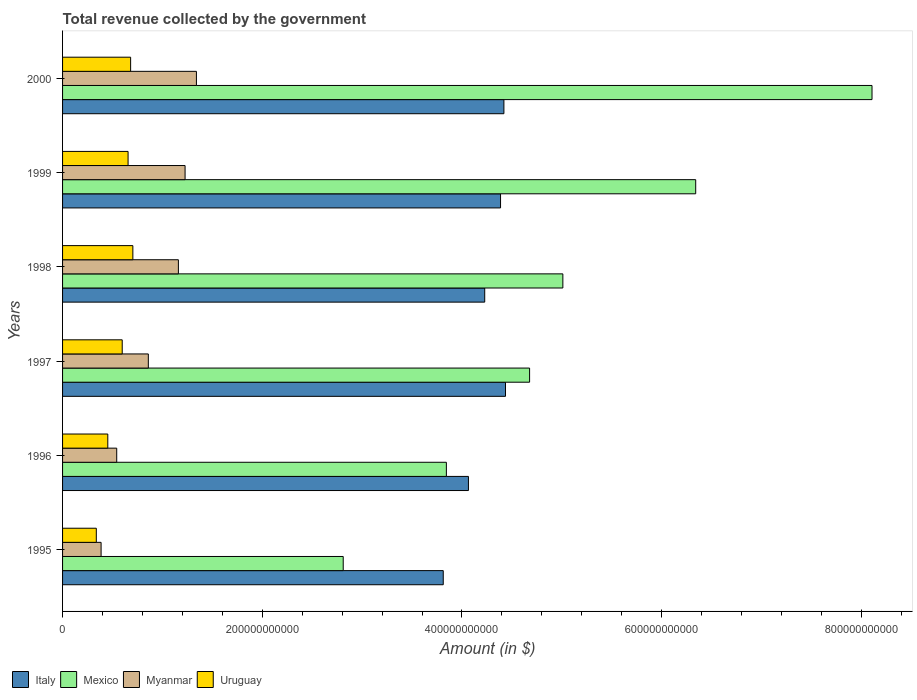How many groups of bars are there?
Provide a short and direct response. 6. Are the number of bars per tick equal to the number of legend labels?
Your answer should be very brief. Yes. Are the number of bars on each tick of the Y-axis equal?
Make the answer very short. Yes. What is the total revenue collected by the government in Italy in 1995?
Ensure brevity in your answer.  3.81e+11. Across all years, what is the maximum total revenue collected by the government in Myanmar?
Provide a succinct answer. 1.34e+11. Across all years, what is the minimum total revenue collected by the government in Italy?
Your answer should be very brief. 3.81e+11. In which year was the total revenue collected by the government in Italy maximum?
Give a very brief answer. 1997. In which year was the total revenue collected by the government in Myanmar minimum?
Keep it short and to the point. 1995. What is the total total revenue collected by the government in Italy in the graph?
Make the answer very short. 2.53e+12. What is the difference between the total revenue collected by the government in Myanmar in 1996 and that in 1997?
Provide a succinct answer. -3.17e+1. What is the difference between the total revenue collected by the government in Uruguay in 1998 and the total revenue collected by the government in Mexico in 1995?
Offer a very short reply. -2.11e+11. What is the average total revenue collected by the government in Uruguay per year?
Your answer should be very brief. 5.72e+1. In the year 1999, what is the difference between the total revenue collected by the government in Italy and total revenue collected by the government in Mexico?
Provide a succinct answer. -1.95e+11. What is the ratio of the total revenue collected by the government in Myanmar in 1996 to that in 1997?
Provide a succinct answer. 0.63. Is the total revenue collected by the government in Mexico in 1996 less than that in 1998?
Your response must be concise. Yes. Is the difference between the total revenue collected by the government in Italy in 1998 and 1999 greater than the difference between the total revenue collected by the government in Mexico in 1998 and 1999?
Your response must be concise. Yes. What is the difference between the highest and the second highest total revenue collected by the government in Italy?
Make the answer very short. 1.59e+09. What is the difference between the highest and the lowest total revenue collected by the government in Mexico?
Ensure brevity in your answer.  5.30e+11. In how many years, is the total revenue collected by the government in Uruguay greater than the average total revenue collected by the government in Uruguay taken over all years?
Provide a short and direct response. 4. Is the sum of the total revenue collected by the government in Mexico in 1998 and 2000 greater than the maximum total revenue collected by the government in Italy across all years?
Your response must be concise. Yes. Is it the case that in every year, the sum of the total revenue collected by the government in Mexico and total revenue collected by the government in Italy is greater than the sum of total revenue collected by the government in Myanmar and total revenue collected by the government in Uruguay?
Provide a succinct answer. No. What does the 2nd bar from the bottom in 1999 represents?
Provide a short and direct response. Mexico. Is it the case that in every year, the sum of the total revenue collected by the government in Uruguay and total revenue collected by the government in Myanmar is greater than the total revenue collected by the government in Mexico?
Provide a succinct answer. No. How many bars are there?
Make the answer very short. 24. Are all the bars in the graph horizontal?
Provide a succinct answer. Yes. What is the difference between two consecutive major ticks on the X-axis?
Offer a terse response. 2.00e+11. Does the graph contain any zero values?
Make the answer very short. No. Does the graph contain grids?
Make the answer very short. No. Where does the legend appear in the graph?
Provide a short and direct response. Bottom left. What is the title of the graph?
Offer a very short reply. Total revenue collected by the government. Does "Andorra" appear as one of the legend labels in the graph?
Offer a very short reply. No. What is the label or title of the X-axis?
Offer a very short reply. Amount (in $). What is the label or title of the Y-axis?
Your answer should be compact. Years. What is the Amount (in $) in Italy in 1995?
Your response must be concise. 3.81e+11. What is the Amount (in $) in Mexico in 1995?
Make the answer very short. 2.81e+11. What is the Amount (in $) of Myanmar in 1995?
Keep it short and to the point. 3.86e+1. What is the Amount (in $) of Uruguay in 1995?
Provide a short and direct response. 3.38e+1. What is the Amount (in $) of Italy in 1996?
Offer a very short reply. 4.06e+11. What is the Amount (in $) of Mexico in 1996?
Keep it short and to the point. 3.84e+11. What is the Amount (in $) of Myanmar in 1996?
Offer a terse response. 5.42e+1. What is the Amount (in $) in Uruguay in 1996?
Keep it short and to the point. 4.53e+1. What is the Amount (in $) in Italy in 1997?
Offer a terse response. 4.44e+11. What is the Amount (in $) of Mexico in 1997?
Make the answer very short. 4.68e+11. What is the Amount (in $) of Myanmar in 1997?
Your response must be concise. 8.59e+1. What is the Amount (in $) of Uruguay in 1997?
Provide a short and direct response. 5.97e+1. What is the Amount (in $) of Italy in 1998?
Keep it short and to the point. 4.23e+11. What is the Amount (in $) of Mexico in 1998?
Your response must be concise. 5.01e+11. What is the Amount (in $) of Myanmar in 1998?
Provide a short and direct response. 1.16e+11. What is the Amount (in $) in Uruguay in 1998?
Your response must be concise. 7.04e+1. What is the Amount (in $) in Italy in 1999?
Ensure brevity in your answer.  4.39e+11. What is the Amount (in $) of Mexico in 1999?
Keep it short and to the point. 6.34e+11. What is the Amount (in $) in Myanmar in 1999?
Make the answer very short. 1.23e+11. What is the Amount (in $) in Uruguay in 1999?
Give a very brief answer. 6.56e+1. What is the Amount (in $) in Italy in 2000?
Make the answer very short. 4.42e+11. What is the Amount (in $) in Mexico in 2000?
Ensure brevity in your answer.  8.11e+11. What is the Amount (in $) in Myanmar in 2000?
Give a very brief answer. 1.34e+11. What is the Amount (in $) of Uruguay in 2000?
Offer a very short reply. 6.82e+1. Across all years, what is the maximum Amount (in $) in Italy?
Keep it short and to the point. 4.44e+11. Across all years, what is the maximum Amount (in $) in Mexico?
Give a very brief answer. 8.11e+11. Across all years, what is the maximum Amount (in $) in Myanmar?
Keep it short and to the point. 1.34e+11. Across all years, what is the maximum Amount (in $) of Uruguay?
Provide a succinct answer. 7.04e+1. Across all years, what is the minimum Amount (in $) in Italy?
Your answer should be compact. 3.81e+11. Across all years, what is the minimum Amount (in $) of Mexico?
Your response must be concise. 2.81e+11. Across all years, what is the minimum Amount (in $) of Myanmar?
Offer a terse response. 3.86e+1. Across all years, what is the minimum Amount (in $) of Uruguay?
Your response must be concise. 3.38e+1. What is the total Amount (in $) in Italy in the graph?
Your response must be concise. 2.53e+12. What is the total Amount (in $) of Mexico in the graph?
Offer a very short reply. 3.08e+12. What is the total Amount (in $) in Myanmar in the graph?
Your answer should be very brief. 5.51e+11. What is the total Amount (in $) in Uruguay in the graph?
Make the answer very short. 3.43e+11. What is the difference between the Amount (in $) of Italy in 1995 and that in 1996?
Give a very brief answer. -2.52e+1. What is the difference between the Amount (in $) of Mexico in 1995 and that in 1996?
Provide a succinct answer. -1.03e+11. What is the difference between the Amount (in $) of Myanmar in 1995 and that in 1996?
Keep it short and to the point. -1.57e+1. What is the difference between the Amount (in $) of Uruguay in 1995 and that in 1996?
Make the answer very short. -1.15e+1. What is the difference between the Amount (in $) in Italy in 1995 and that in 1997?
Offer a terse response. -6.23e+1. What is the difference between the Amount (in $) of Mexico in 1995 and that in 1997?
Make the answer very short. -1.87e+11. What is the difference between the Amount (in $) in Myanmar in 1995 and that in 1997?
Provide a short and direct response. -4.73e+1. What is the difference between the Amount (in $) in Uruguay in 1995 and that in 1997?
Give a very brief answer. -2.59e+1. What is the difference between the Amount (in $) of Italy in 1995 and that in 1998?
Give a very brief answer. -4.15e+1. What is the difference between the Amount (in $) of Mexico in 1995 and that in 1998?
Offer a terse response. -2.20e+11. What is the difference between the Amount (in $) in Myanmar in 1995 and that in 1998?
Offer a very short reply. -7.74e+1. What is the difference between the Amount (in $) in Uruguay in 1995 and that in 1998?
Offer a very short reply. -3.66e+1. What is the difference between the Amount (in $) in Italy in 1995 and that in 1999?
Your answer should be very brief. -5.74e+1. What is the difference between the Amount (in $) of Mexico in 1995 and that in 1999?
Your answer should be very brief. -3.53e+11. What is the difference between the Amount (in $) in Myanmar in 1995 and that in 1999?
Offer a terse response. -8.41e+1. What is the difference between the Amount (in $) in Uruguay in 1995 and that in 1999?
Give a very brief answer. -3.18e+1. What is the difference between the Amount (in $) of Italy in 1995 and that in 2000?
Offer a terse response. -6.08e+1. What is the difference between the Amount (in $) of Mexico in 1995 and that in 2000?
Keep it short and to the point. -5.30e+11. What is the difference between the Amount (in $) of Myanmar in 1995 and that in 2000?
Your response must be concise. -9.55e+1. What is the difference between the Amount (in $) in Uruguay in 1995 and that in 2000?
Your answer should be very brief. -3.44e+1. What is the difference between the Amount (in $) of Italy in 1996 and that in 1997?
Keep it short and to the point. -3.71e+1. What is the difference between the Amount (in $) of Mexico in 1996 and that in 1997?
Provide a succinct answer. -8.33e+1. What is the difference between the Amount (in $) of Myanmar in 1996 and that in 1997?
Make the answer very short. -3.17e+1. What is the difference between the Amount (in $) of Uruguay in 1996 and that in 1997?
Provide a succinct answer. -1.45e+1. What is the difference between the Amount (in $) of Italy in 1996 and that in 1998?
Provide a succinct answer. -1.63e+1. What is the difference between the Amount (in $) in Mexico in 1996 and that in 1998?
Give a very brief answer. -1.17e+11. What is the difference between the Amount (in $) of Myanmar in 1996 and that in 1998?
Provide a succinct answer. -6.18e+1. What is the difference between the Amount (in $) of Uruguay in 1996 and that in 1998?
Offer a very short reply. -2.51e+1. What is the difference between the Amount (in $) of Italy in 1996 and that in 1999?
Your answer should be very brief. -3.22e+1. What is the difference between the Amount (in $) of Mexico in 1996 and that in 1999?
Your answer should be compact. -2.50e+11. What is the difference between the Amount (in $) of Myanmar in 1996 and that in 1999?
Provide a succinct answer. -6.84e+1. What is the difference between the Amount (in $) in Uruguay in 1996 and that in 1999?
Keep it short and to the point. -2.03e+1. What is the difference between the Amount (in $) in Italy in 1996 and that in 2000?
Your response must be concise. -3.55e+1. What is the difference between the Amount (in $) in Mexico in 1996 and that in 2000?
Offer a terse response. -4.26e+11. What is the difference between the Amount (in $) of Myanmar in 1996 and that in 2000?
Provide a short and direct response. -7.98e+1. What is the difference between the Amount (in $) of Uruguay in 1996 and that in 2000?
Provide a succinct answer. -2.29e+1. What is the difference between the Amount (in $) in Italy in 1997 and that in 1998?
Provide a short and direct response. 2.08e+1. What is the difference between the Amount (in $) in Mexico in 1997 and that in 1998?
Offer a terse response. -3.33e+1. What is the difference between the Amount (in $) in Myanmar in 1997 and that in 1998?
Your response must be concise. -3.01e+1. What is the difference between the Amount (in $) in Uruguay in 1997 and that in 1998?
Your response must be concise. -1.06e+1. What is the difference between the Amount (in $) in Italy in 1997 and that in 1999?
Your response must be concise. 4.96e+09. What is the difference between the Amount (in $) of Mexico in 1997 and that in 1999?
Ensure brevity in your answer.  -1.66e+11. What is the difference between the Amount (in $) in Myanmar in 1997 and that in 1999?
Make the answer very short. -3.68e+1. What is the difference between the Amount (in $) of Uruguay in 1997 and that in 1999?
Your response must be concise. -5.86e+09. What is the difference between the Amount (in $) in Italy in 1997 and that in 2000?
Provide a short and direct response. 1.59e+09. What is the difference between the Amount (in $) of Mexico in 1997 and that in 2000?
Keep it short and to the point. -3.43e+11. What is the difference between the Amount (in $) of Myanmar in 1997 and that in 2000?
Keep it short and to the point. -4.82e+1. What is the difference between the Amount (in $) of Uruguay in 1997 and that in 2000?
Offer a terse response. -8.42e+09. What is the difference between the Amount (in $) of Italy in 1998 and that in 1999?
Offer a terse response. -1.58e+1. What is the difference between the Amount (in $) in Mexico in 1998 and that in 1999?
Ensure brevity in your answer.  -1.33e+11. What is the difference between the Amount (in $) in Myanmar in 1998 and that in 1999?
Keep it short and to the point. -6.70e+09. What is the difference between the Amount (in $) of Uruguay in 1998 and that in 1999?
Ensure brevity in your answer.  4.78e+09. What is the difference between the Amount (in $) in Italy in 1998 and that in 2000?
Ensure brevity in your answer.  -1.92e+1. What is the difference between the Amount (in $) in Mexico in 1998 and that in 2000?
Offer a very short reply. -3.10e+11. What is the difference between the Amount (in $) in Myanmar in 1998 and that in 2000?
Offer a very short reply. -1.81e+1. What is the difference between the Amount (in $) of Uruguay in 1998 and that in 2000?
Your response must be concise. 2.23e+09. What is the difference between the Amount (in $) in Italy in 1999 and that in 2000?
Ensure brevity in your answer.  -3.37e+09. What is the difference between the Amount (in $) in Mexico in 1999 and that in 2000?
Make the answer very short. -1.77e+11. What is the difference between the Amount (in $) of Myanmar in 1999 and that in 2000?
Ensure brevity in your answer.  -1.14e+1. What is the difference between the Amount (in $) of Uruguay in 1999 and that in 2000?
Make the answer very short. -2.55e+09. What is the difference between the Amount (in $) in Italy in 1995 and the Amount (in $) in Mexico in 1996?
Your response must be concise. -3.14e+09. What is the difference between the Amount (in $) of Italy in 1995 and the Amount (in $) of Myanmar in 1996?
Make the answer very short. 3.27e+11. What is the difference between the Amount (in $) of Italy in 1995 and the Amount (in $) of Uruguay in 1996?
Offer a terse response. 3.36e+11. What is the difference between the Amount (in $) in Mexico in 1995 and the Amount (in $) in Myanmar in 1996?
Keep it short and to the point. 2.27e+11. What is the difference between the Amount (in $) of Mexico in 1995 and the Amount (in $) of Uruguay in 1996?
Make the answer very short. 2.36e+11. What is the difference between the Amount (in $) in Myanmar in 1995 and the Amount (in $) in Uruguay in 1996?
Ensure brevity in your answer.  -6.71e+09. What is the difference between the Amount (in $) in Italy in 1995 and the Amount (in $) in Mexico in 1997?
Keep it short and to the point. -8.65e+1. What is the difference between the Amount (in $) in Italy in 1995 and the Amount (in $) in Myanmar in 1997?
Offer a terse response. 2.95e+11. What is the difference between the Amount (in $) of Italy in 1995 and the Amount (in $) of Uruguay in 1997?
Offer a terse response. 3.21e+11. What is the difference between the Amount (in $) of Mexico in 1995 and the Amount (in $) of Myanmar in 1997?
Provide a short and direct response. 1.95e+11. What is the difference between the Amount (in $) in Mexico in 1995 and the Amount (in $) in Uruguay in 1997?
Ensure brevity in your answer.  2.21e+11. What is the difference between the Amount (in $) in Myanmar in 1995 and the Amount (in $) in Uruguay in 1997?
Your answer should be very brief. -2.12e+1. What is the difference between the Amount (in $) in Italy in 1995 and the Amount (in $) in Mexico in 1998?
Your answer should be compact. -1.20e+11. What is the difference between the Amount (in $) in Italy in 1995 and the Amount (in $) in Myanmar in 1998?
Your answer should be compact. 2.65e+11. What is the difference between the Amount (in $) in Italy in 1995 and the Amount (in $) in Uruguay in 1998?
Your answer should be compact. 3.11e+11. What is the difference between the Amount (in $) of Mexico in 1995 and the Amount (in $) of Myanmar in 1998?
Your answer should be compact. 1.65e+11. What is the difference between the Amount (in $) of Mexico in 1995 and the Amount (in $) of Uruguay in 1998?
Offer a very short reply. 2.11e+11. What is the difference between the Amount (in $) in Myanmar in 1995 and the Amount (in $) in Uruguay in 1998?
Offer a very short reply. -3.18e+1. What is the difference between the Amount (in $) in Italy in 1995 and the Amount (in $) in Mexico in 1999?
Your answer should be compact. -2.53e+11. What is the difference between the Amount (in $) in Italy in 1995 and the Amount (in $) in Myanmar in 1999?
Give a very brief answer. 2.59e+11. What is the difference between the Amount (in $) of Italy in 1995 and the Amount (in $) of Uruguay in 1999?
Your response must be concise. 3.16e+11. What is the difference between the Amount (in $) in Mexico in 1995 and the Amount (in $) in Myanmar in 1999?
Make the answer very short. 1.58e+11. What is the difference between the Amount (in $) in Mexico in 1995 and the Amount (in $) in Uruguay in 1999?
Give a very brief answer. 2.15e+11. What is the difference between the Amount (in $) of Myanmar in 1995 and the Amount (in $) of Uruguay in 1999?
Your response must be concise. -2.70e+1. What is the difference between the Amount (in $) of Italy in 1995 and the Amount (in $) of Mexico in 2000?
Your response must be concise. -4.29e+11. What is the difference between the Amount (in $) of Italy in 1995 and the Amount (in $) of Myanmar in 2000?
Provide a short and direct response. 2.47e+11. What is the difference between the Amount (in $) of Italy in 1995 and the Amount (in $) of Uruguay in 2000?
Your response must be concise. 3.13e+11. What is the difference between the Amount (in $) of Mexico in 1995 and the Amount (in $) of Myanmar in 2000?
Provide a short and direct response. 1.47e+11. What is the difference between the Amount (in $) of Mexico in 1995 and the Amount (in $) of Uruguay in 2000?
Ensure brevity in your answer.  2.13e+11. What is the difference between the Amount (in $) of Myanmar in 1995 and the Amount (in $) of Uruguay in 2000?
Offer a terse response. -2.96e+1. What is the difference between the Amount (in $) in Italy in 1996 and the Amount (in $) in Mexico in 1997?
Provide a short and direct response. -6.12e+1. What is the difference between the Amount (in $) in Italy in 1996 and the Amount (in $) in Myanmar in 1997?
Your answer should be very brief. 3.21e+11. What is the difference between the Amount (in $) of Italy in 1996 and the Amount (in $) of Uruguay in 1997?
Make the answer very short. 3.47e+11. What is the difference between the Amount (in $) of Mexico in 1996 and the Amount (in $) of Myanmar in 1997?
Make the answer very short. 2.98e+11. What is the difference between the Amount (in $) of Mexico in 1996 and the Amount (in $) of Uruguay in 1997?
Ensure brevity in your answer.  3.25e+11. What is the difference between the Amount (in $) in Myanmar in 1996 and the Amount (in $) in Uruguay in 1997?
Provide a succinct answer. -5.51e+09. What is the difference between the Amount (in $) of Italy in 1996 and the Amount (in $) of Mexico in 1998?
Give a very brief answer. -9.46e+1. What is the difference between the Amount (in $) of Italy in 1996 and the Amount (in $) of Myanmar in 1998?
Ensure brevity in your answer.  2.90e+11. What is the difference between the Amount (in $) of Italy in 1996 and the Amount (in $) of Uruguay in 1998?
Offer a terse response. 3.36e+11. What is the difference between the Amount (in $) of Mexico in 1996 and the Amount (in $) of Myanmar in 1998?
Your answer should be compact. 2.68e+11. What is the difference between the Amount (in $) of Mexico in 1996 and the Amount (in $) of Uruguay in 1998?
Ensure brevity in your answer.  3.14e+11. What is the difference between the Amount (in $) in Myanmar in 1996 and the Amount (in $) in Uruguay in 1998?
Make the answer very short. -1.62e+1. What is the difference between the Amount (in $) in Italy in 1996 and the Amount (in $) in Mexico in 1999?
Your answer should be very brief. -2.28e+11. What is the difference between the Amount (in $) in Italy in 1996 and the Amount (in $) in Myanmar in 1999?
Your response must be concise. 2.84e+11. What is the difference between the Amount (in $) of Italy in 1996 and the Amount (in $) of Uruguay in 1999?
Your response must be concise. 3.41e+11. What is the difference between the Amount (in $) in Mexico in 1996 and the Amount (in $) in Myanmar in 1999?
Keep it short and to the point. 2.62e+11. What is the difference between the Amount (in $) in Mexico in 1996 and the Amount (in $) in Uruguay in 1999?
Offer a very short reply. 3.19e+11. What is the difference between the Amount (in $) of Myanmar in 1996 and the Amount (in $) of Uruguay in 1999?
Make the answer very short. -1.14e+1. What is the difference between the Amount (in $) of Italy in 1996 and the Amount (in $) of Mexico in 2000?
Make the answer very short. -4.04e+11. What is the difference between the Amount (in $) in Italy in 1996 and the Amount (in $) in Myanmar in 2000?
Your answer should be compact. 2.72e+11. What is the difference between the Amount (in $) in Italy in 1996 and the Amount (in $) in Uruguay in 2000?
Provide a short and direct response. 3.38e+11. What is the difference between the Amount (in $) in Mexico in 1996 and the Amount (in $) in Myanmar in 2000?
Make the answer very short. 2.50e+11. What is the difference between the Amount (in $) of Mexico in 1996 and the Amount (in $) of Uruguay in 2000?
Offer a terse response. 3.16e+11. What is the difference between the Amount (in $) in Myanmar in 1996 and the Amount (in $) in Uruguay in 2000?
Keep it short and to the point. -1.39e+1. What is the difference between the Amount (in $) in Italy in 1997 and the Amount (in $) in Mexico in 1998?
Your answer should be very brief. -5.75e+1. What is the difference between the Amount (in $) in Italy in 1997 and the Amount (in $) in Myanmar in 1998?
Your answer should be very brief. 3.28e+11. What is the difference between the Amount (in $) of Italy in 1997 and the Amount (in $) of Uruguay in 1998?
Offer a very short reply. 3.73e+11. What is the difference between the Amount (in $) in Mexico in 1997 and the Amount (in $) in Myanmar in 1998?
Keep it short and to the point. 3.52e+11. What is the difference between the Amount (in $) of Mexico in 1997 and the Amount (in $) of Uruguay in 1998?
Provide a short and direct response. 3.97e+11. What is the difference between the Amount (in $) of Myanmar in 1997 and the Amount (in $) of Uruguay in 1998?
Offer a terse response. 1.55e+1. What is the difference between the Amount (in $) of Italy in 1997 and the Amount (in $) of Mexico in 1999?
Give a very brief answer. -1.90e+11. What is the difference between the Amount (in $) of Italy in 1997 and the Amount (in $) of Myanmar in 1999?
Keep it short and to the point. 3.21e+11. What is the difference between the Amount (in $) of Italy in 1997 and the Amount (in $) of Uruguay in 1999?
Your answer should be very brief. 3.78e+11. What is the difference between the Amount (in $) of Mexico in 1997 and the Amount (in $) of Myanmar in 1999?
Offer a terse response. 3.45e+11. What is the difference between the Amount (in $) in Mexico in 1997 and the Amount (in $) in Uruguay in 1999?
Offer a very short reply. 4.02e+11. What is the difference between the Amount (in $) of Myanmar in 1997 and the Amount (in $) of Uruguay in 1999?
Provide a short and direct response. 2.03e+1. What is the difference between the Amount (in $) of Italy in 1997 and the Amount (in $) of Mexico in 2000?
Make the answer very short. -3.67e+11. What is the difference between the Amount (in $) in Italy in 1997 and the Amount (in $) in Myanmar in 2000?
Offer a very short reply. 3.10e+11. What is the difference between the Amount (in $) in Italy in 1997 and the Amount (in $) in Uruguay in 2000?
Make the answer very short. 3.75e+11. What is the difference between the Amount (in $) in Mexico in 1997 and the Amount (in $) in Myanmar in 2000?
Give a very brief answer. 3.34e+11. What is the difference between the Amount (in $) of Mexico in 1997 and the Amount (in $) of Uruguay in 2000?
Keep it short and to the point. 4.00e+11. What is the difference between the Amount (in $) in Myanmar in 1997 and the Amount (in $) in Uruguay in 2000?
Your answer should be very brief. 1.77e+1. What is the difference between the Amount (in $) in Italy in 1998 and the Amount (in $) in Mexico in 1999?
Keep it short and to the point. -2.11e+11. What is the difference between the Amount (in $) in Italy in 1998 and the Amount (in $) in Myanmar in 1999?
Give a very brief answer. 3.00e+11. What is the difference between the Amount (in $) in Italy in 1998 and the Amount (in $) in Uruguay in 1999?
Keep it short and to the point. 3.57e+11. What is the difference between the Amount (in $) of Mexico in 1998 and the Amount (in $) of Myanmar in 1999?
Ensure brevity in your answer.  3.78e+11. What is the difference between the Amount (in $) in Mexico in 1998 and the Amount (in $) in Uruguay in 1999?
Your response must be concise. 4.35e+11. What is the difference between the Amount (in $) in Myanmar in 1998 and the Amount (in $) in Uruguay in 1999?
Your answer should be very brief. 5.04e+1. What is the difference between the Amount (in $) of Italy in 1998 and the Amount (in $) of Mexico in 2000?
Provide a short and direct response. -3.88e+11. What is the difference between the Amount (in $) of Italy in 1998 and the Amount (in $) of Myanmar in 2000?
Your response must be concise. 2.89e+11. What is the difference between the Amount (in $) of Italy in 1998 and the Amount (in $) of Uruguay in 2000?
Ensure brevity in your answer.  3.55e+11. What is the difference between the Amount (in $) in Mexico in 1998 and the Amount (in $) in Myanmar in 2000?
Your answer should be compact. 3.67e+11. What is the difference between the Amount (in $) in Mexico in 1998 and the Amount (in $) in Uruguay in 2000?
Offer a terse response. 4.33e+11. What is the difference between the Amount (in $) in Myanmar in 1998 and the Amount (in $) in Uruguay in 2000?
Make the answer very short. 4.78e+1. What is the difference between the Amount (in $) in Italy in 1999 and the Amount (in $) in Mexico in 2000?
Your response must be concise. -3.72e+11. What is the difference between the Amount (in $) of Italy in 1999 and the Amount (in $) of Myanmar in 2000?
Make the answer very short. 3.05e+11. What is the difference between the Amount (in $) in Italy in 1999 and the Amount (in $) in Uruguay in 2000?
Provide a succinct answer. 3.70e+11. What is the difference between the Amount (in $) in Mexico in 1999 and the Amount (in $) in Myanmar in 2000?
Offer a very short reply. 5.00e+11. What is the difference between the Amount (in $) of Mexico in 1999 and the Amount (in $) of Uruguay in 2000?
Your response must be concise. 5.66e+11. What is the difference between the Amount (in $) of Myanmar in 1999 and the Amount (in $) of Uruguay in 2000?
Keep it short and to the point. 5.45e+1. What is the average Amount (in $) in Italy per year?
Your response must be concise. 4.22e+11. What is the average Amount (in $) of Mexico per year?
Your response must be concise. 5.13e+11. What is the average Amount (in $) of Myanmar per year?
Give a very brief answer. 9.19e+1. What is the average Amount (in $) of Uruguay per year?
Provide a succinct answer. 5.72e+1. In the year 1995, what is the difference between the Amount (in $) in Italy and Amount (in $) in Mexico?
Ensure brevity in your answer.  1.00e+11. In the year 1995, what is the difference between the Amount (in $) in Italy and Amount (in $) in Myanmar?
Your answer should be compact. 3.43e+11. In the year 1995, what is the difference between the Amount (in $) in Italy and Amount (in $) in Uruguay?
Your answer should be very brief. 3.47e+11. In the year 1995, what is the difference between the Amount (in $) of Mexico and Amount (in $) of Myanmar?
Ensure brevity in your answer.  2.42e+11. In the year 1995, what is the difference between the Amount (in $) of Mexico and Amount (in $) of Uruguay?
Offer a terse response. 2.47e+11. In the year 1995, what is the difference between the Amount (in $) in Myanmar and Amount (in $) in Uruguay?
Provide a succinct answer. 4.78e+09. In the year 1996, what is the difference between the Amount (in $) in Italy and Amount (in $) in Mexico?
Keep it short and to the point. 2.21e+1. In the year 1996, what is the difference between the Amount (in $) of Italy and Amount (in $) of Myanmar?
Your response must be concise. 3.52e+11. In the year 1996, what is the difference between the Amount (in $) in Italy and Amount (in $) in Uruguay?
Give a very brief answer. 3.61e+11. In the year 1996, what is the difference between the Amount (in $) of Mexico and Amount (in $) of Myanmar?
Ensure brevity in your answer.  3.30e+11. In the year 1996, what is the difference between the Amount (in $) of Mexico and Amount (in $) of Uruguay?
Give a very brief answer. 3.39e+11. In the year 1996, what is the difference between the Amount (in $) of Myanmar and Amount (in $) of Uruguay?
Ensure brevity in your answer.  8.94e+09. In the year 1997, what is the difference between the Amount (in $) in Italy and Amount (in $) in Mexico?
Make the answer very short. -2.41e+1. In the year 1997, what is the difference between the Amount (in $) of Italy and Amount (in $) of Myanmar?
Provide a short and direct response. 3.58e+11. In the year 1997, what is the difference between the Amount (in $) of Italy and Amount (in $) of Uruguay?
Give a very brief answer. 3.84e+11. In the year 1997, what is the difference between the Amount (in $) of Mexico and Amount (in $) of Myanmar?
Your answer should be very brief. 3.82e+11. In the year 1997, what is the difference between the Amount (in $) of Mexico and Amount (in $) of Uruguay?
Give a very brief answer. 4.08e+11. In the year 1997, what is the difference between the Amount (in $) of Myanmar and Amount (in $) of Uruguay?
Provide a short and direct response. 2.61e+1. In the year 1998, what is the difference between the Amount (in $) in Italy and Amount (in $) in Mexico?
Ensure brevity in your answer.  -7.83e+1. In the year 1998, what is the difference between the Amount (in $) in Italy and Amount (in $) in Myanmar?
Provide a short and direct response. 3.07e+11. In the year 1998, what is the difference between the Amount (in $) of Italy and Amount (in $) of Uruguay?
Make the answer very short. 3.52e+11. In the year 1998, what is the difference between the Amount (in $) in Mexico and Amount (in $) in Myanmar?
Keep it short and to the point. 3.85e+11. In the year 1998, what is the difference between the Amount (in $) of Mexico and Amount (in $) of Uruguay?
Provide a succinct answer. 4.31e+11. In the year 1998, what is the difference between the Amount (in $) in Myanmar and Amount (in $) in Uruguay?
Offer a very short reply. 4.56e+1. In the year 1999, what is the difference between the Amount (in $) in Italy and Amount (in $) in Mexico?
Your response must be concise. -1.95e+11. In the year 1999, what is the difference between the Amount (in $) in Italy and Amount (in $) in Myanmar?
Ensure brevity in your answer.  3.16e+11. In the year 1999, what is the difference between the Amount (in $) of Italy and Amount (in $) of Uruguay?
Provide a succinct answer. 3.73e+11. In the year 1999, what is the difference between the Amount (in $) of Mexico and Amount (in $) of Myanmar?
Your response must be concise. 5.11e+11. In the year 1999, what is the difference between the Amount (in $) in Mexico and Amount (in $) in Uruguay?
Ensure brevity in your answer.  5.68e+11. In the year 1999, what is the difference between the Amount (in $) of Myanmar and Amount (in $) of Uruguay?
Give a very brief answer. 5.71e+1. In the year 2000, what is the difference between the Amount (in $) in Italy and Amount (in $) in Mexico?
Your answer should be very brief. -3.69e+11. In the year 2000, what is the difference between the Amount (in $) in Italy and Amount (in $) in Myanmar?
Keep it short and to the point. 3.08e+11. In the year 2000, what is the difference between the Amount (in $) in Italy and Amount (in $) in Uruguay?
Offer a very short reply. 3.74e+11. In the year 2000, what is the difference between the Amount (in $) in Mexico and Amount (in $) in Myanmar?
Give a very brief answer. 6.77e+11. In the year 2000, what is the difference between the Amount (in $) of Mexico and Amount (in $) of Uruguay?
Keep it short and to the point. 7.42e+11. In the year 2000, what is the difference between the Amount (in $) in Myanmar and Amount (in $) in Uruguay?
Keep it short and to the point. 6.59e+1. What is the ratio of the Amount (in $) in Italy in 1995 to that in 1996?
Your response must be concise. 0.94. What is the ratio of the Amount (in $) in Mexico in 1995 to that in 1996?
Make the answer very short. 0.73. What is the ratio of the Amount (in $) in Myanmar in 1995 to that in 1996?
Provide a succinct answer. 0.71. What is the ratio of the Amount (in $) of Uruguay in 1995 to that in 1996?
Give a very brief answer. 0.75. What is the ratio of the Amount (in $) of Italy in 1995 to that in 1997?
Offer a terse response. 0.86. What is the ratio of the Amount (in $) of Mexico in 1995 to that in 1997?
Your answer should be very brief. 0.6. What is the ratio of the Amount (in $) of Myanmar in 1995 to that in 1997?
Keep it short and to the point. 0.45. What is the ratio of the Amount (in $) of Uruguay in 1995 to that in 1997?
Provide a succinct answer. 0.57. What is the ratio of the Amount (in $) in Italy in 1995 to that in 1998?
Your response must be concise. 0.9. What is the ratio of the Amount (in $) in Mexico in 1995 to that in 1998?
Make the answer very short. 0.56. What is the ratio of the Amount (in $) of Myanmar in 1995 to that in 1998?
Your answer should be very brief. 0.33. What is the ratio of the Amount (in $) of Uruguay in 1995 to that in 1998?
Your response must be concise. 0.48. What is the ratio of the Amount (in $) in Italy in 1995 to that in 1999?
Your response must be concise. 0.87. What is the ratio of the Amount (in $) in Mexico in 1995 to that in 1999?
Offer a very short reply. 0.44. What is the ratio of the Amount (in $) in Myanmar in 1995 to that in 1999?
Your answer should be compact. 0.31. What is the ratio of the Amount (in $) in Uruguay in 1995 to that in 1999?
Offer a terse response. 0.52. What is the ratio of the Amount (in $) in Italy in 1995 to that in 2000?
Offer a very short reply. 0.86. What is the ratio of the Amount (in $) in Mexico in 1995 to that in 2000?
Give a very brief answer. 0.35. What is the ratio of the Amount (in $) of Myanmar in 1995 to that in 2000?
Your response must be concise. 0.29. What is the ratio of the Amount (in $) of Uruguay in 1995 to that in 2000?
Your answer should be very brief. 0.5. What is the ratio of the Amount (in $) of Italy in 1996 to that in 1997?
Make the answer very short. 0.92. What is the ratio of the Amount (in $) of Mexico in 1996 to that in 1997?
Your answer should be compact. 0.82. What is the ratio of the Amount (in $) in Myanmar in 1996 to that in 1997?
Provide a succinct answer. 0.63. What is the ratio of the Amount (in $) of Uruguay in 1996 to that in 1997?
Offer a very short reply. 0.76. What is the ratio of the Amount (in $) in Italy in 1996 to that in 1998?
Provide a short and direct response. 0.96. What is the ratio of the Amount (in $) in Mexico in 1996 to that in 1998?
Your answer should be compact. 0.77. What is the ratio of the Amount (in $) of Myanmar in 1996 to that in 1998?
Provide a short and direct response. 0.47. What is the ratio of the Amount (in $) in Uruguay in 1996 to that in 1998?
Keep it short and to the point. 0.64. What is the ratio of the Amount (in $) of Italy in 1996 to that in 1999?
Make the answer very short. 0.93. What is the ratio of the Amount (in $) of Mexico in 1996 to that in 1999?
Your answer should be compact. 0.61. What is the ratio of the Amount (in $) in Myanmar in 1996 to that in 1999?
Provide a succinct answer. 0.44. What is the ratio of the Amount (in $) of Uruguay in 1996 to that in 1999?
Provide a short and direct response. 0.69. What is the ratio of the Amount (in $) in Italy in 1996 to that in 2000?
Provide a short and direct response. 0.92. What is the ratio of the Amount (in $) in Mexico in 1996 to that in 2000?
Ensure brevity in your answer.  0.47. What is the ratio of the Amount (in $) in Myanmar in 1996 to that in 2000?
Make the answer very short. 0.4. What is the ratio of the Amount (in $) of Uruguay in 1996 to that in 2000?
Make the answer very short. 0.66. What is the ratio of the Amount (in $) in Italy in 1997 to that in 1998?
Offer a terse response. 1.05. What is the ratio of the Amount (in $) in Mexico in 1997 to that in 1998?
Offer a terse response. 0.93. What is the ratio of the Amount (in $) in Myanmar in 1997 to that in 1998?
Provide a succinct answer. 0.74. What is the ratio of the Amount (in $) of Uruguay in 1997 to that in 1998?
Ensure brevity in your answer.  0.85. What is the ratio of the Amount (in $) of Italy in 1997 to that in 1999?
Keep it short and to the point. 1.01. What is the ratio of the Amount (in $) in Mexico in 1997 to that in 1999?
Provide a short and direct response. 0.74. What is the ratio of the Amount (in $) of Myanmar in 1997 to that in 1999?
Give a very brief answer. 0.7. What is the ratio of the Amount (in $) in Uruguay in 1997 to that in 1999?
Your answer should be very brief. 0.91. What is the ratio of the Amount (in $) in Italy in 1997 to that in 2000?
Offer a terse response. 1. What is the ratio of the Amount (in $) in Mexico in 1997 to that in 2000?
Offer a very short reply. 0.58. What is the ratio of the Amount (in $) in Myanmar in 1997 to that in 2000?
Give a very brief answer. 0.64. What is the ratio of the Amount (in $) in Uruguay in 1997 to that in 2000?
Ensure brevity in your answer.  0.88. What is the ratio of the Amount (in $) of Italy in 1998 to that in 1999?
Offer a very short reply. 0.96. What is the ratio of the Amount (in $) of Mexico in 1998 to that in 1999?
Give a very brief answer. 0.79. What is the ratio of the Amount (in $) in Myanmar in 1998 to that in 1999?
Your answer should be compact. 0.95. What is the ratio of the Amount (in $) of Uruguay in 1998 to that in 1999?
Your response must be concise. 1.07. What is the ratio of the Amount (in $) of Italy in 1998 to that in 2000?
Give a very brief answer. 0.96. What is the ratio of the Amount (in $) of Mexico in 1998 to that in 2000?
Your answer should be compact. 0.62. What is the ratio of the Amount (in $) in Myanmar in 1998 to that in 2000?
Provide a short and direct response. 0.87. What is the ratio of the Amount (in $) of Uruguay in 1998 to that in 2000?
Offer a terse response. 1.03. What is the ratio of the Amount (in $) in Italy in 1999 to that in 2000?
Give a very brief answer. 0.99. What is the ratio of the Amount (in $) of Mexico in 1999 to that in 2000?
Your response must be concise. 0.78. What is the ratio of the Amount (in $) of Myanmar in 1999 to that in 2000?
Provide a succinct answer. 0.92. What is the ratio of the Amount (in $) in Uruguay in 1999 to that in 2000?
Keep it short and to the point. 0.96. What is the difference between the highest and the second highest Amount (in $) in Italy?
Offer a terse response. 1.59e+09. What is the difference between the highest and the second highest Amount (in $) in Mexico?
Your response must be concise. 1.77e+11. What is the difference between the highest and the second highest Amount (in $) in Myanmar?
Provide a short and direct response. 1.14e+1. What is the difference between the highest and the second highest Amount (in $) of Uruguay?
Offer a terse response. 2.23e+09. What is the difference between the highest and the lowest Amount (in $) in Italy?
Ensure brevity in your answer.  6.23e+1. What is the difference between the highest and the lowest Amount (in $) of Mexico?
Keep it short and to the point. 5.30e+11. What is the difference between the highest and the lowest Amount (in $) of Myanmar?
Offer a very short reply. 9.55e+1. What is the difference between the highest and the lowest Amount (in $) of Uruguay?
Provide a short and direct response. 3.66e+1. 